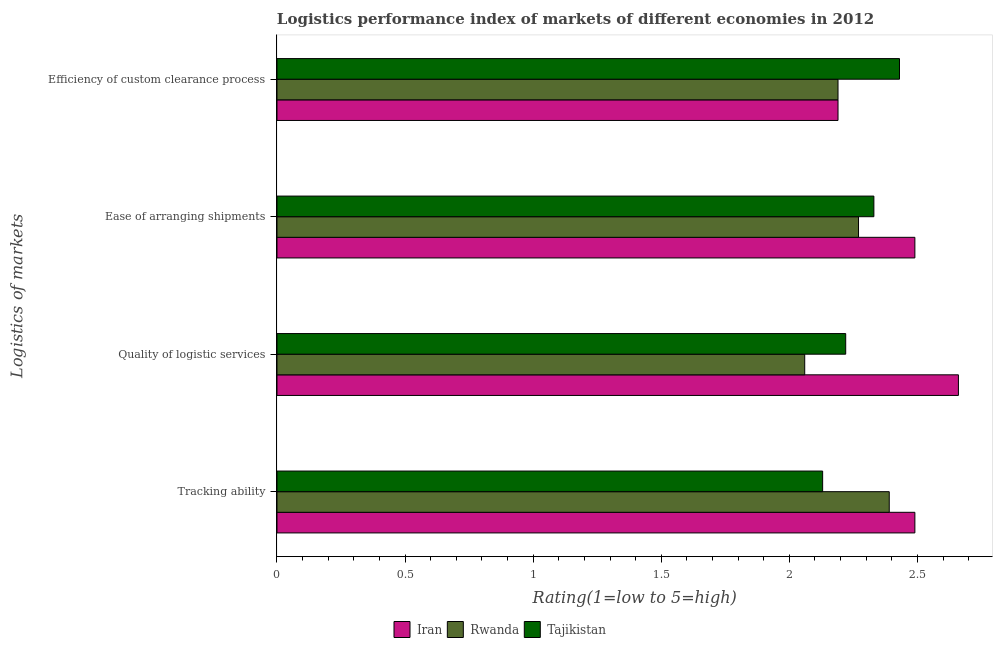Are the number of bars per tick equal to the number of legend labels?
Give a very brief answer. Yes. Are the number of bars on each tick of the Y-axis equal?
Keep it short and to the point. Yes. How many bars are there on the 2nd tick from the bottom?
Keep it short and to the point. 3. What is the label of the 3rd group of bars from the top?
Give a very brief answer. Quality of logistic services. What is the lpi rating of ease of arranging shipments in Iran?
Your answer should be compact. 2.49. Across all countries, what is the maximum lpi rating of quality of logistic services?
Your response must be concise. 2.66. Across all countries, what is the minimum lpi rating of quality of logistic services?
Make the answer very short. 2.06. In which country was the lpi rating of ease of arranging shipments maximum?
Keep it short and to the point. Iran. In which country was the lpi rating of efficiency of custom clearance process minimum?
Your response must be concise. Iran. What is the total lpi rating of efficiency of custom clearance process in the graph?
Make the answer very short. 6.81. What is the difference between the lpi rating of quality of logistic services in Iran and that in Tajikistan?
Provide a succinct answer. 0.44. What is the difference between the lpi rating of efficiency of custom clearance process in Iran and the lpi rating of tracking ability in Tajikistan?
Keep it short and to the point. 0.06. What is the average lpi rating of tracking ability per country?
Keep it short and to the point. 2.34. What is the difference between the lpi rating of tracking ability and lpi rating of efficiency of custom clearance process in Iran?
Keep it short and to the point. 0.3. What is the ratio of the lpi rating of tracking ability in Tajikistan to that in Iran?
Offer a terse response. 0.86. Is the lpi rating of efficiency of custom clearance process in Iran less than that in Tajikistan?
Provide a succinct answer. Yes. What is the difference between the highest and the second highest lpi rating of efficiency of custom clearance process?
Provide a succinct answer. 0.24. What is the difference between the highest and the lowest lpi rating of efficiency of custom clearance process?
Your answer should be very brief. 0.24. In how many countries, is the lpi rating of tracking ability greater than the average lpi rating of tracking ability taken over all countries?
Keep it short and to the point. 2. What does the 2nd bar from the top in Tracking ability represents?
Ensure brevity in your answer.  Rwanda. What does the 2nd bar from the bottom in Quality of logistic services represents?
Make the answer very short. Rwanda. Is it the case that in every country, the sum of the lpi rating of tracking ability and lpi rating of quality of logistic services is greater than the lpi rating of ease of arranging shipments?
Your answer should be very brief. Yes. Are the values on the major ticks of X-axis written in scientific E-notation?
Your answer should be compact. No. Does the graph contain any zero values?
Keep it short and to the point. No. Where does the legend appear in the graph?
Keep it short and to the point. Bottom center. How many legend labels are there?
Keep it short and to the point. 3. What is the title of the graph?
Your response must be concise. Logistics performance index of markets of different economies in 2012. What is the label or title of the X-axis?
Keep it short and to the point. Rating(1=low to 5=high). What is the label or title of the Y-axis?
Your answer should be compact. Logistics of markets. What is the Rating(1=low to 5=high) in Iran in Tracking ability?
Provide a succinct answer. 2.49. What is the Rating(1=low to 5=high) of Rwanda in Tracking ability?
Give a very brief answer. 2.39. What is the Rating(1=low to 5=high) of Tajikistan in Tracking ability?
Provide a short and direct response. 2.13. What is the Rating(1=low to 5=high) of Iran in Quality of logistic services?
Offer a very short reply. 2.66. What is the Rating(1=low to 5=high) of Rwanda in Quality of logistic services?
Give a very brief answer. 2.06. What is the Rating(1=low to 5=high) in Tajikistan in Quality of logistic services?
Give a very brief answer. 2.22. What is the Rating(1=low to 5=high) in Iran in Ease of arranging shipments?
Offer a very short reply. 2.49. What is the Rating(1=low to 5=high) of Rwanda in Ease of arranging shipments?
Your response must be concise. 2.27. What is the Rating(1=low to 5=high) of Tajikistan in Ease of arranging shipments?
Offer a terse response. 2.33. What is the Rating(1=low to 5=high) in Iran in Efficiency of custom clearance process?
Make the answer very short. 2.19. What is the Rating(1=low to 5=high) of Rwanda in Efficiency of custom clearance process?
Make the answer very short. 2.19. What is the Rating(1=low to 5=high) of Tajikistan in Efficiency of custom clearance process?
Give a very brief answer. 2.43. Across all Logistics of markets, what is the maximum Rating(1=low to 5=high) in Iran?
Provide a short and direct response. 2.66. Across all Logistics of markets, what is the maximum Rating(1=low to 5=high) of Rwanda?
Provide a short and direct response. 2.39. Across all Logistics of markets, what is the maximum Rating(1=low to 5=high) of Tajikistan?
Provide a short and direct response. 2.43. Across all Logistics of markets, what is the minimum Rating(1=low to 5=high) of Iran?
Your response must be concise. 2.19. Across all Logistics of markets, what is the minimum Rating(1=low to 5=high) of Rwanda?
Offer a very short reply. 2.06. Across all Logistics of markets, what is the minimum Rating(1=low to 5=high) in Tajikistan?
Your answer should be very brief. 2.13. What is the total Rating(1=low to 5=high) of Iran in the graph?
Your response must be concise. 9.83. What is the total Rating(1=low to 5=high) of Rwanda in the graph?
Offer a very short reply. 8.91. What is the total Rating(1=low to 5=high) in Tajikistan in the graph?
Offer a terse response. 9.11. What is the difference between the Rating(1=low to 5=high) in Iran in Tracking ability and that in Quality of logistic services?
Make the answer very short. -0.17. What is the difference between the Rating(1=low to 5=high) of Rwanda in Tracking ability and that in Quality of logistic services?
Keep it short and to the point. 0.33. What is the difference between the Rating(1=low to 5=high) in Tajikistan in Tracking ability and that in Quality of logistic services?
Give a very brief answer. -0.09. What is the difference between the Rating(1=low to 5=high) in Rwanda in Tracking ability and that in Ease of arranging shipments?
Your answer should be compact. 0.12. What is the difference between the Rating(1=low to 5=high) of Tajikistan in Tracking ability and that in Ease of arranging shipments?
Your answer should be compact. -0.2. What is the difference between the Rating(1=low to 5=high) of Iran in Tracking ability and that in Efficiency of custom clearance process?
Ensure brevity in your answer.  0.3. What is the difference between the Rating(1=low to 5=high) of Tajikistan in Tracking ability and that in Efficiency of custom clearance process?
Provide a short and direct response. -0.3. What is the difference between the Rating(1=low to 5=high) of Iran in Quality of logistic services and that in Ease of arranging shipments?
Your answer should be very brief. 0.17. What is the difference between the Rating(1=low to 5=high) of Rwanda in Quality of logistic services and that in Ease of arranging shipments?
Make the answer very short. -0.21. What is the difference between the Rating(1=low to 5=high) of Tajikistan in Quality of logistic services and that in Ease of arranging shipments?
Offer a very short reply. -0.11. What is the difference between the Rating(1=low to 5=high) of Iran in Quality of logistic services and that in Efficiency of custom clearance process?
Make the answer very short. 0.47. What is the difference between the Rating(1=low to 5=high) in Rwanda in Quality of logistic services and that in Efficiency of custom clearance process?
Offer a very short reply. -0.13. What is the difference between the Rating(1=low to 5=high) of Tajikistan in Quality of logistic services and that in Efficiency of custom clearance process?
Provide a succinct answer. -0.21. What is the difference between the Rating(1=low to 5=high) in Iran in Ease of arranging shipments and that in Efficiency of custom clearance process?
Provide a succinct answer. 0.3. What is the difference between the Rating(1=low to 5=high) of Rwanda in Ease of arranging shipments and that in Efficiency of custom clearance process?
Keep it short and to the point. 0.08. What is the difference between the Rating(1=low to 5=high) of Tajikistan in Ease of arranging shipments and that in Efficiency of custom clearance process?
Make the answer very short. -0.1. What is the difference between the Rating(1=low to 5=high) in Iran in Tracking ability and the Rating(1=low to 5=high) in Rwanda in Quality of logistic services?
Make the answer very short. 0.43. What is the difference between the Rating(1=low to 5=high) in Iran in Tracking ability and the Rating(1=low to 5=high) in Tajikistan in Quality of logistic services?
Make the answer very short. 0.27. What is the difference between the Rating(1=low to 5=high) of Rwanda in Tracking ability and the Rating(1=low to 5=high) of Tajikistan in Quality of logistic services?
Offer a terse response. 0.17. What is the difference between the Rating(1=low to 5=high) of Iran in Tracking ability and the Rating(1=low to 5=high) of Rwanda in Ease of arranging shipments?
Your answer should be very brief. 0.22. What is the difference between the Rating(1=low to 5=high) in Iran in Tracking ability and the Rating(1=low to 5=high) in Tajikistan in Ease of arranging shipments?
Ensure brevity in your answer.  0.16. What is the difference between the Rating(1=low to 5=high) of Rwanda in Tracking ability and the Rating(1=low to 5=high) of Tajikistan in Efficiency of custom clearance process?
Ensure brevity in your answer.  -0.04. What is the difference between the Rating(1=low to 5=high) of Iran in Quality of logistic services and the Rating(1=low to 5=high) of Rwanda in Ease of arranging shipments?
Keep it short and to the point. 0.39. What is the difference between the Rating(1=low to 5=high) of Iran in Quality of logistic services and the Rating(1=low to 5=high) of Tajikistan in Ease of arranging shipments?
Your answer should be very brief. 0.33. What is the difference between the Rating(1=low to 5=high) of Rwanda in Quality of logistic services and the Rating(1=low to 5=high) of Tajikistan in Ease of arranging shipments?
Offer a terse response. -0.27. What is the difference between the Rating(1=low to 5=high) of Iran in Quality of logistic services and the Rating(1=low to 5=high) of Rwanda in Efficiency of custom clearance process?
Keep it short and to the point. 0.47. What is the difference between the Rating(1=low to 5=high) in Iran in Quality of logistic services and the Rating(1=low to 5=high) in Tajikistan in Efficiency of custom clearance process?
Provide a short and direct response. 0.23. What is the difference between the Rating(1=low to 5=high) of Rwanda in Quality of logistic services and the Rating(1=low to 5=high) of Tajikistan in Efficiency of custom clearance process?
Make the answer very short. -0.37. What is the difference between the Rating(1=low to 5=high) in Iran in Ease of arranging shipments and the Rating(1=low to 5=high) in Tajikistan in Efficiency of custom clearance process?
Make the answer very short. 0.06. What is the difference between the Rating(1=low to 5=high) of Rwanda in Ease of arranging shipments and the Rating(1=low to 5=high) of Tajikistan in Efficiency of custom clearance process?
Your answer should be compact. -0.16. What is the average Rating(1=low to 5=high) in Iran per Logistics of markets?
Your answer should be very brief. 2.46. What is the average Rating(1=low to 5=high) in Rwanda per Logistics of markets?
Your response must be concise. 2.23. What is the average Rating(1=low to 5=high) of Tajikistan per Logistics of markets?
Provide a short and direct response. 2.28. What is the difference between the Rating(1=low to 5=high) of Iran and Rating(1=low to 5=high) of Rwanda in Tracking ability?
Your answer should be very brief. 0.1. What is the difference between the Rating(1=low to 5=high) in Iran and Rating(1=low to 5=high) in Tajikistan in Tracking ability?
Make the answer very short. 0.36. What is the difference between the Rating(1=low to 5=high) of Rwanda and Rating(1=low to 5=high) of Tajikistan in Tracking ability?
Make the answer very short. 0.26. What is the difference between the Rating(1=low to 5=high) of Iran and Rating(1=low to 5=high) of Tajikistan in Quality of logistic services?
Keep it short and to the point. 0.44. What is the difference between the Rating(1=low to 5=high) in Rwanda and Rating(1=low to 5=high) in Tajikistan in Quality of logistic services?
Make the answer very short. -0.16. What is the difference between the Rating(1=low to 5=high) in Iran and Rating(1=low to 5=high) in Rwanda in Ease of arranging shipments?
Your answer should be compact. 0.22. What is the difference between the Rating(1=low to 5=high) in Iran and Rating(1=low to 5=high) in Tajikistan in Ease of arranging shipments?
Your answer should be very brief. 0.16. What is the difference between the Rating(1=low to 5=high) of Rwanda and Rating(1=low to 5=high) of Tajikistan in Ease of arranging shipments?
Provide a short and direct response. -0.06. What is the difference between the Rating(1=low to 5=high) of Iran and Rating(1=low to 5=high) of Rwanda in Efficiency of custom clearance process?
Provide a succinct answer. 0. What is the difference between the Rating(1=low to 5=high) of Iran and Rating(1=low to 5=high) of Tajikistan in Efficiency of custom clearance process?
Your answer should be very brief. -0.24. What is the difference between the Rating(1=low to 5=high) in Rwanda and Rating(1=low to 5=high) in Tajikistan in Efficiency of custom clearance process?
Make the answer very short. -0.24. What is the ratio of the Rating(1=low to 5=high) of Iran in Tracking ability to that in Quality of logistic services?
Offer a terse response. 0.94. What is the ratio of the Rating(1=low to 5=high) in Rwanda in Tracking ability to that in Quality of logistic services?
Keep it short and to the point. 1.16. What is the ratio of the Rating(1=low to 5=high) of Tajikistan in Tracking ability to that in Quality of logistic services?
Your answer should be very brief. 0.96. What is the ratio of the Rating(1=low to 5=high) of Iran in Tracking ability to that in Ease of arranging shipments?
Give a very brief answer. 1. What is the ratio of the Rating(1=low to 5=high) of Rwanda in Tracking ability to that in Ease of arranging shipments?
Your answer should be very brief. 1.05. What is the ratio of the Rating(1=low to 5=high) of Tajikistan in Tracking ability to that in Ease of arranging shipments?
Make the answer very short. 0.91. What is the ratio of the Rating(1=low to 5=high) in Iran in Tracking ability to that in Efficiency of custom clearance process?
Provide a short and direct response. 1.14. What is the ratio of the Rating(1=low to 5=high) in Rwanda in Tracking ability to that in Efficiency of custom clearance process?
Your response must be concise. 1.09. What is the ratio of the Rating(1=low to 5=high) of Tajikistan in Tracking ability to that in Efficiency of custom clearance process?
Ensure brevity in your answer.  0.88. What is the ratio of the Rating(1=low to 5=high) in Iran in Quality of logistic services to that in Ease of arranging shipments?
Provide a succinct answer. 1.07. What is the ratio of the Rating(1=low to 5=high) in Rwanda in Quality of logistic services to that in Ease of arranging shipments?
Your answer should be compact. 0.91. What is the ratio of the Rating(1=low to 5=high) of Tajikistan in Quality of logistic services to that in Ease of arranging shipments?
Your response must be concise. 0.95. What is the ratio of the Rating(1=low to 5=high) of Iran in Quality of logistic services to that in Efficiency of custom clearance process?
Offer a terse response. 1.21. What is the ratio of the Rating(1=low to 5=high) of Rwanda in Quality of logistic services to that in Efficiency of custom clearance process?
Keep it short and to the point. 0.94. What is the ratio of the Rating(1=low to 5=high) of Tajikistan in Quality of logistic services to that in Efficiency of custom clearance process?
Give a very brief answer. 0.91. What is the ratio of the Rating(1=low to 5=high) in Iran in Ease of arranging shipments to that in Efficiency of custom clearance process?
Provide a succinct answer. 1.14. What is the ratio of the Rating(1=low to 5=high) in Rwanda in Ease of arranging shipments to that in Efficiency of custom clearance process?
Your response must be concise. 1.04. What is the ratio of the Rating(1=low to 5=high) of Tajikistan in Ease of arranging shipments to that in Efficiency of custom clearance process?
Ensure brevity in your answer.  0.96. What is the difference between the highest and the second highest Rating(1=low to 5=high) of Iran?
Give a very brief answer. 0.17. What is the difference between the highest and the second highest Rating(1=low to 5=high) in Rwanda?
Provide a succinct answer. 0.12. What is the difference between the highest and the second highest Rating(1=low to 5=high) in Tajikistan?
Your response must be concise. 0.1. What is the difference between the highest and the lowest Rating(1=low to 5=high) of Iran?
Your response must be concise. 0.47. What is the difference between the highest and the lowest Rating(1=low to 5=high) in Rwanda?
Provide a succinct answer. 0.33. What is the difference between the highest and the lowest Rating(1=low to 5=high) in Tajikistan?
Make the answer very short. 0.3. 